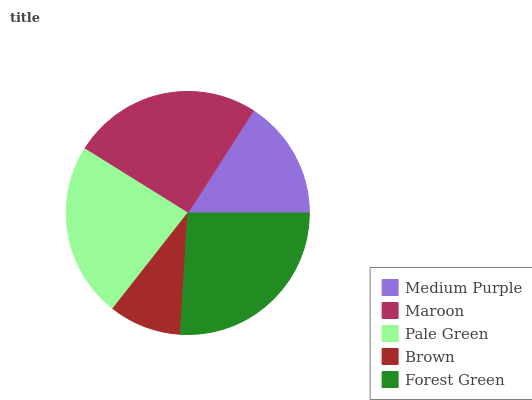Is Brown the minimum?
Answer yes or no. Yes. Is Forest Green the maximum?
Answer yes or no. Yes. Is Maroon the minimum?
Answer yes or no. No. Is Maroon the maximum?
Answer yes or no. No. Is Maroon greater than Medium Purple?
Answer yes or no. Yes. Is Medium Purple less than Maroon?
Answer yes or no. Yes. Is Medium Purple greater than Maroon?
Answer yes or no. No. Is Maroon less than Medium Purple?
Answer yes or no. No. Is Pale Green the high median?
Answer yes or no. Yes. Is Pale Green the low median?
Answer yes or no. Yes. Is Maroon the high median?
Answer yes or no. No. Is Medium Purple the low median?
Answer yes or no. No. 